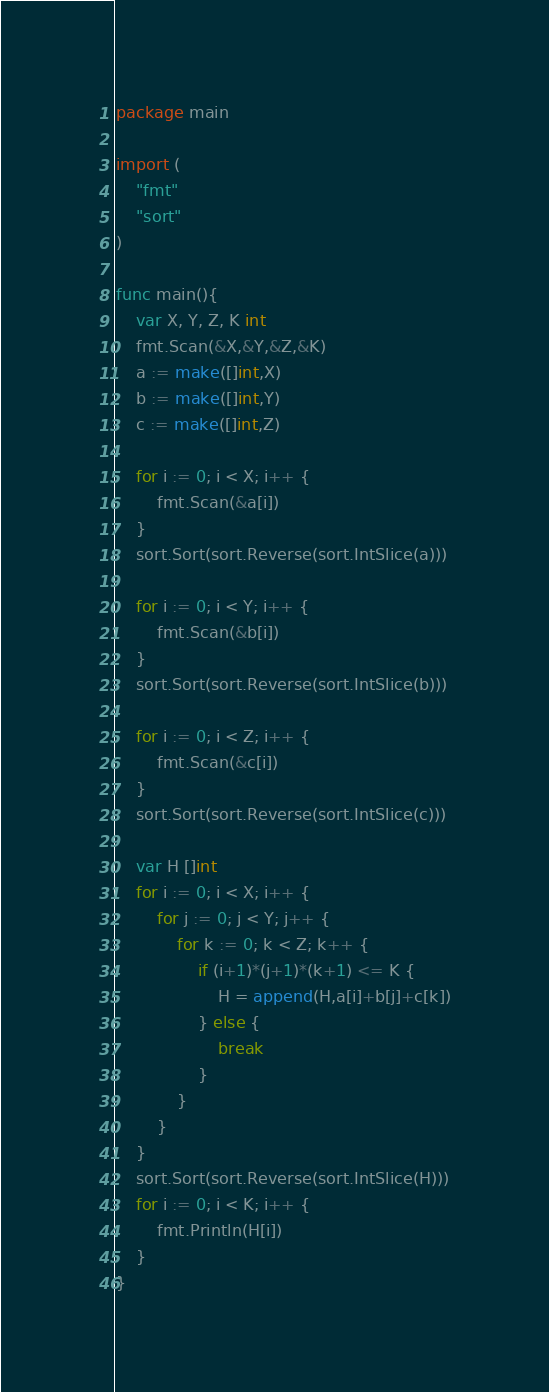Convert code to text. <code><loc_0><loc_0><loc_500><loc_500><_Go_>package main

import (
	"fmt"
	"sort"
)

func main(){
	var X, Y, Z, K int
	fmt.Scan(&X,&Y,&Z,&K)
	a := make([]int,X)
	b := make([]int,Y)
	c := make([]int,Z)

	for i := 0; i < X; i++ {
		fmt.Scan(&a[i])
	}
	sort.Sort(sort.Reverse(sort.IntSlice(a)))

	for i := 0; i < Y; i++ {
		fmt.Scan(&b[i])
	}
	sort.Sort(sort.Reverse(sort.IntSlice(b)))

	for i := 0; i < Z; i++ {
		fmt.Scan(&c[i])
	}
	sort.Sort(sort.Reverse(sort.IntSlice(c)))

	var H []int
	for i := 0; i < X; i++ {
		for j := 0; j < Y; j++ {
			for k := 0; k < Z; k++ {
				if (i+1)*(j+1)*(k+1) <= K {
					H = append(H,a[i]+b[j]+c[k])
				} else {
					break
				}
			}
		}
	}
	sort.Sort(sort.Reverse(sort.IntSlice(H)))
	for i := 0; i < K; i++ {
		fmt.Println(H[i])
	}
}
</code> 